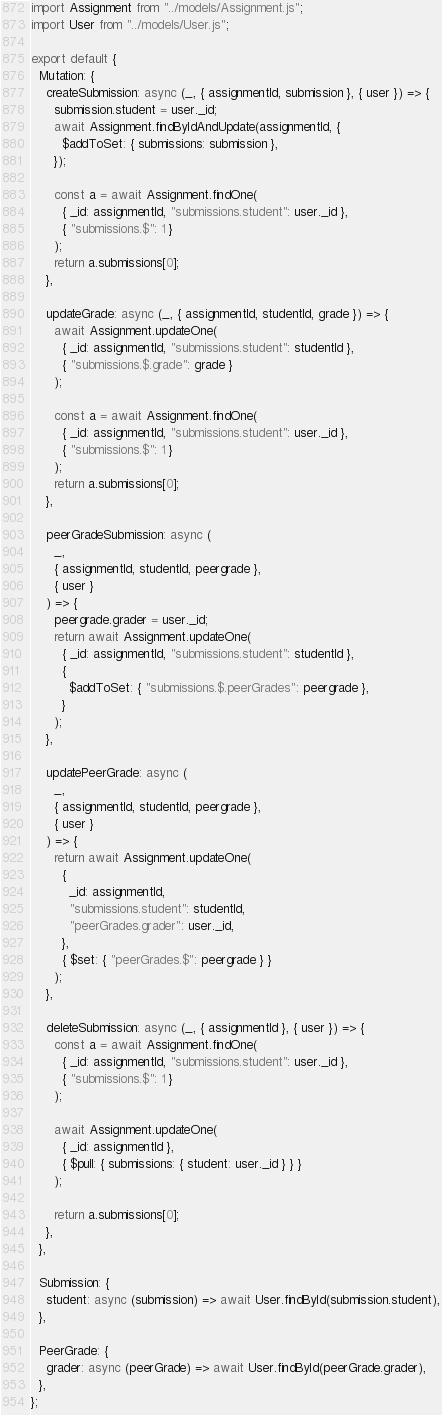Convert code to text. <code><loc_0><loc_0><loc_500><loc_500><_JavaScript_>import Assignment from "../models/Assignment.js";
import User from "../models/User.js";

export default {
  Mutation: {
    createSubmission: async (_, { assignmentId, submission }, { user }) => {
      submission.student = user._id;
      await Assignment.findByIdAndUpdate(assignmentId, {
        $addToSet: { submissions: submission },
      });

      const a = await Assignment.findOne(
        { _id: assignmentId, "submissions.student": user._id },
        { "submissions.$": 1 }
      );
      return a.submissions[0];
    },

    updateGrade: async (_, { assignmentId, studentId, grade }) => {
      await Assignment.updateOne(
        { _id: assignmentId, "submissions.student": studentId },
        { "submissions.$.grade": grade }
      );

      const a = await Assignment.findOne(
        { _id: assignmentId, "submissions.student": user._id },
        { "submissions.$": 1 }
      );
      return a.submissions[0];
    },

    peerGradeSubmission: async (
      _,
      { assignmentId, studentId, peergrade },
      { user }
    ) => {
      peergrade.grader = user._id;
      return await Assignment.updateOne(
        { _id: assignmentId, "submissions.student": studentId },
        {
          $addToSet: { "submissions.$.peerGrades": peergrade },
        }
      );
    },

    updatePeerGrade: async (
      _,
      { assignmentId, studentId, peergrade },
      { user }
    ) => {
      return await Assignment.updateOne(
        {
          _id: assignmentId,
          "submissions.student": studentId,
          "peerGrades.grader": user._id,
        },
        { $set: { "peerGrades.$": peergrade } }
      );
    },

    deleteSubmission: async (_, { assignmentId }, { user }) => {
      const a = await Assignment.findOne(
        { _id: assignmentId, "submissions.student": user._id },
        { "submissions.$": 1 }
      );

      await Assignment.updateOne(
        { _id: assignmentId },
        { $pull: { submissions: { student: user._id } } }
      );

      return a.submissions[0];
    },
  },

  Submission: {
    student: async (submission) => await User.findById(submission.student),
  },

  PeerGrade: {
    grader: async (peerGrade) => await User.findById(peerGrade.grader),
  },
};
</code> 